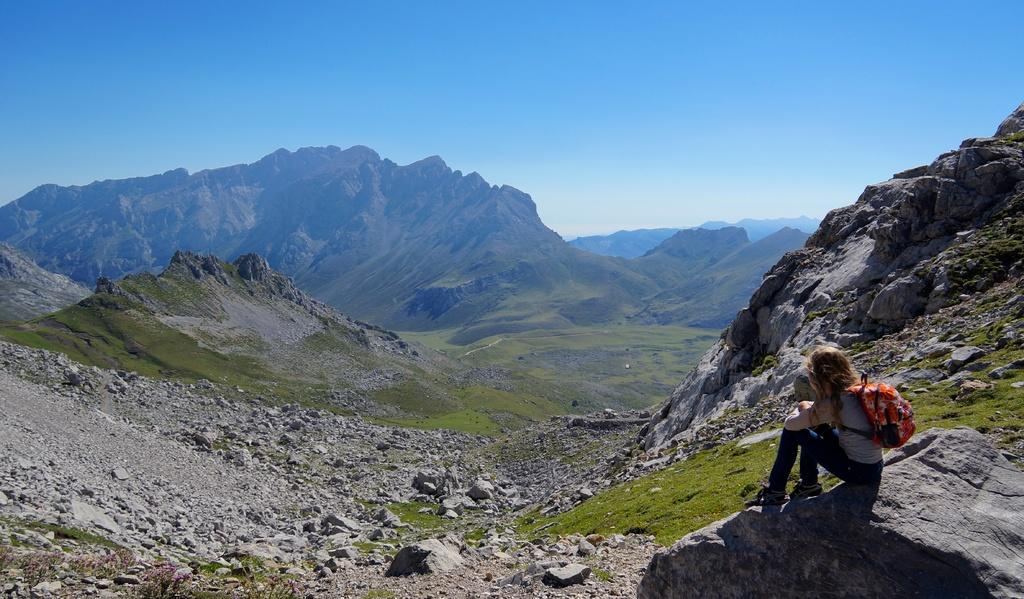What is the person in the image doing? The person is sitting on a rock in the image. What is the person carrying with them? The person is carrying a bag on their shoulders. What type of terrain is visible in the background? There are stones and grass on the ground in the background. What natural features can be seen in the distance? There are mountains visible in the background. What is visible above the mountains? The sky is visible in the background. What type of sea creature can be seen crawling out of the box in the image? There is no sea creature or box present in the image. 